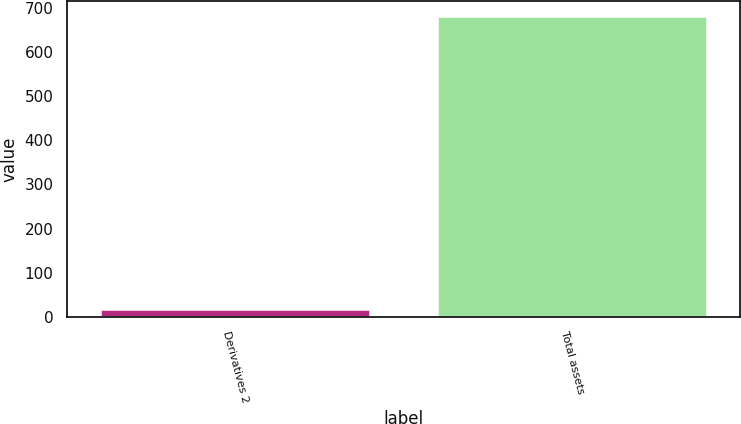Convert chart. <chart><loc_0><loc_0><loc_500><loc_500><bar_chart><fcel>Derivatives 2<fcel>Total assets<nl><fcel>19<fcel>682<nl></chart> 